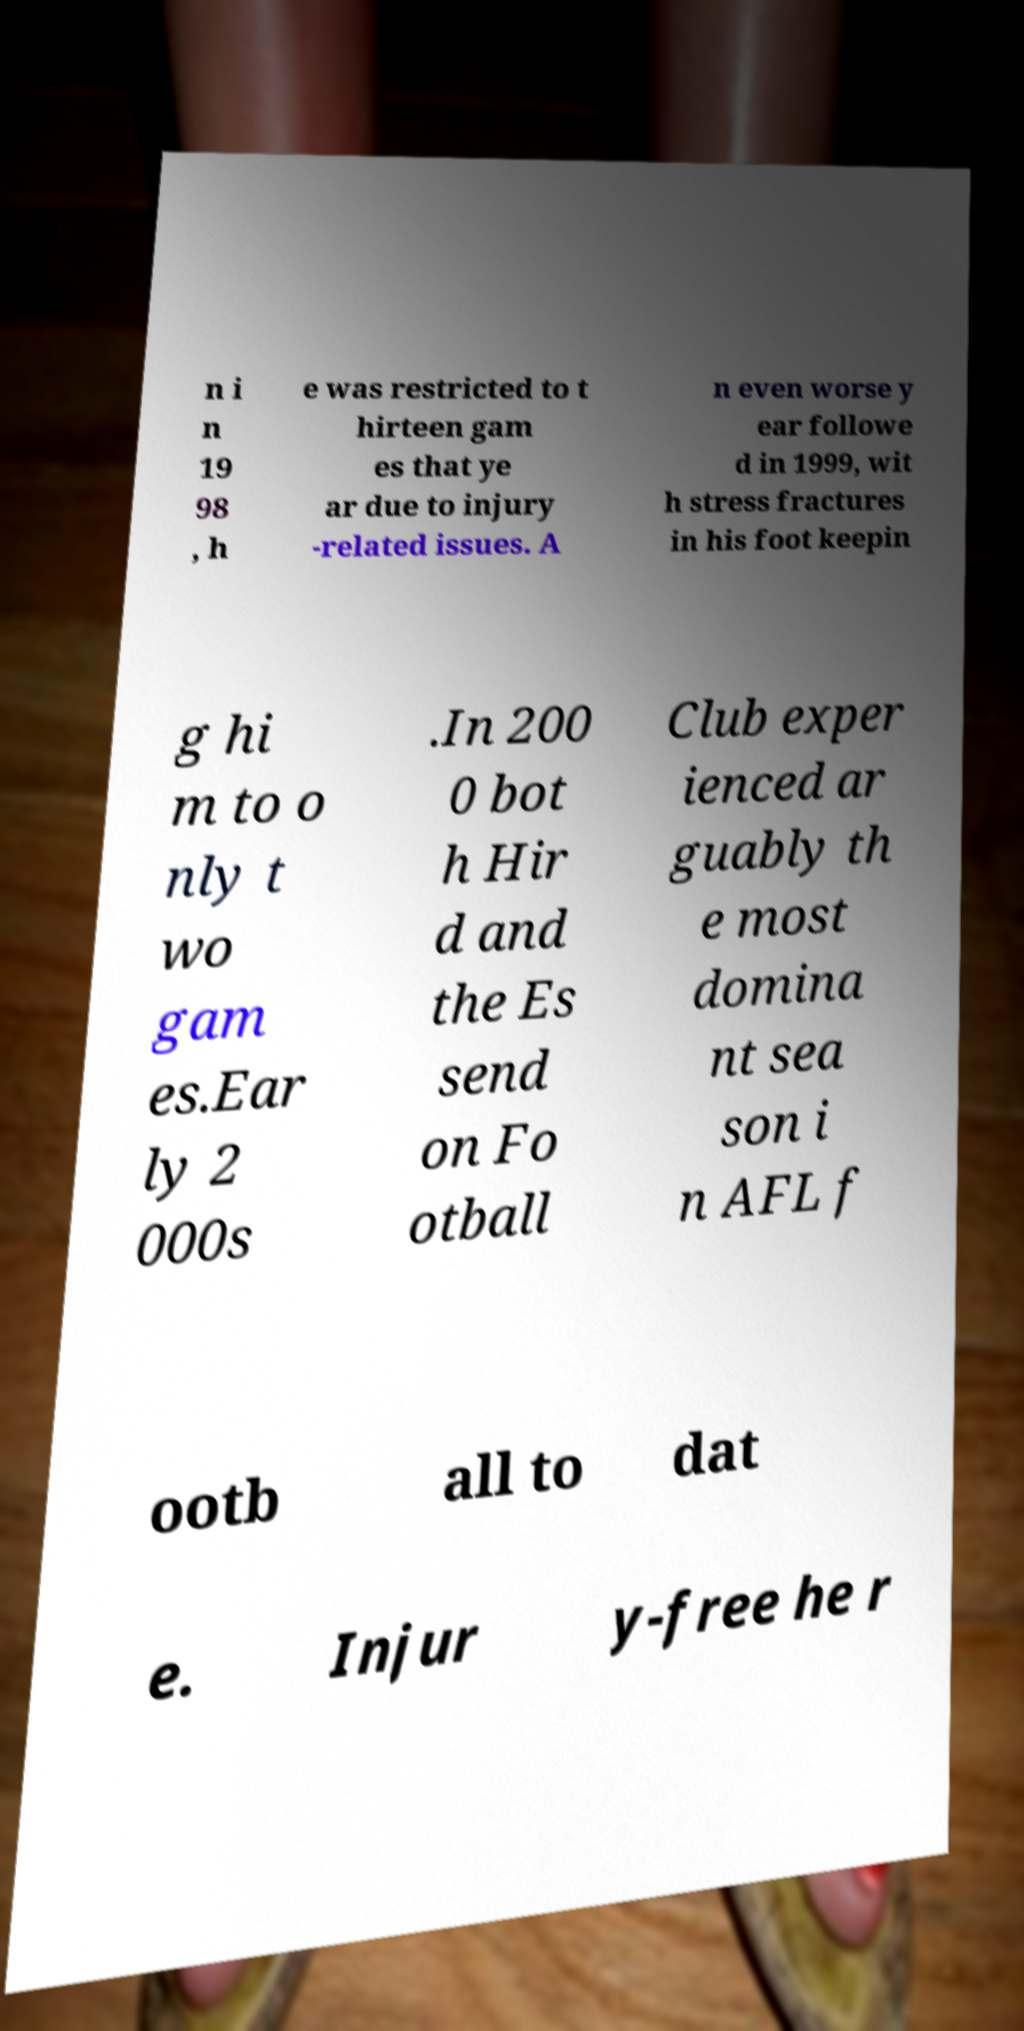Please identify and transcribe the text found in this image. n i n 19 98 , h e was restricted to t hirteen gam es that ye ar due to injury -related issues. A n even worse y ear followe d in 1999, wit h stress fractures in his foot keepin g hi m to o nly t wo gam es.Ear ly 2 000s .In 200 0 bot h Hir d and the Es send on Fo otball Club exper ienced ar guably th e most domina nt sea son i n AFL f ootb all to dat e. Injur y-free he r 